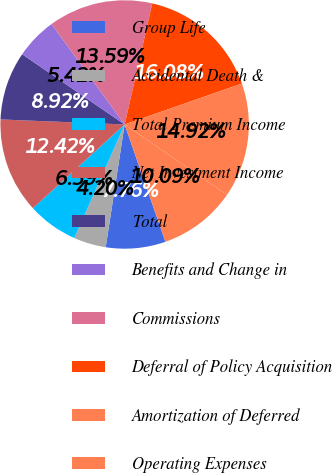Convert chart to OTSL. <chart><loc_0><loc_0><loc_500><loc_500><pie_chart><fcel>Group Life<fcel>Accidental Death &<fcel>Total Premium Income<fcel>Net Investment Income<fcel>Total<fcel>Benefits and Change in<fcel>Commissions<fcel>Deferral of Policy Acquisition<fcel>Amortization of Deferred<fcel>Operating Expenses<nl><fcel>7.76%<fcel>4.2%<fcel>6.59%<fcel>12.42%<fcel>8.92%<fcel>5.42%<fcel>13.59%<fcel>16.08%<fcel>14.92%<fcel>10.09%<nl></chart> 